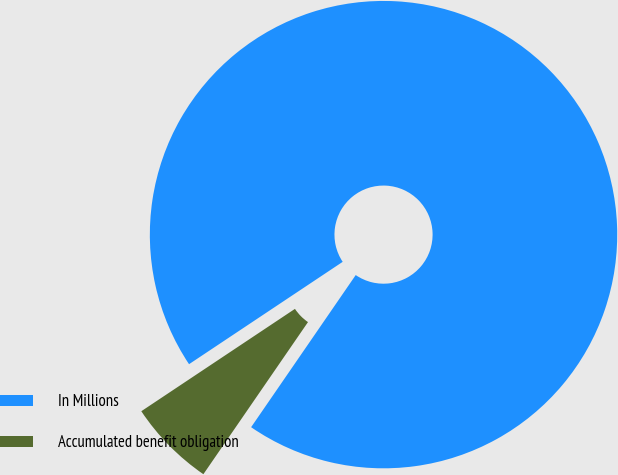<chart> <loc_0><loc_0><loc_500><loc_500><pie_chart><fcel>In Millions<fcel>Accumulated benefit obligation<nl><fcel>93.94%<fcel>6.06%<nl></chart> 